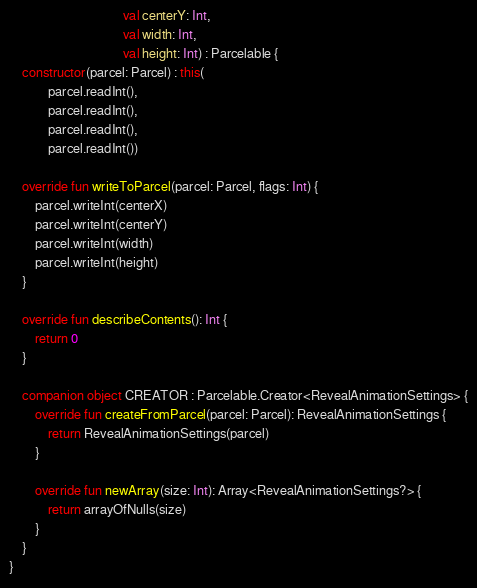Convert code to text. <code><loc_0><loc_0><loc_500><loc_500><_Kotlin_>                                   val centerY: Int,
                                   val width: Int,
                                   val height: Int) : Parcelable {
    constructor(parcel: Parcel) : this(
            parcel.readInt(),
            parcel.readInt(),
            parcel.readInt(),
            parcel.readInt())

    override fun writeToParcel(parcel: Parcel, flags: Int) {
        parcel.writeInt(centerX)
        parcel.writeInt(centerY)
        parcel.writeInt(width)
        parcel.writeInt(height)
    }

    override fun describeContents(): Int {
        return 0
    }

    companion object CREATOR : Parcelable.Creator<RevealAnimationSettings> {
        override fun createFromParcel(parcel: Parcel): RevealAnimationSettings {
            return RevealAnimationSettings(parcel)
        }

        override fun newArray(size: Int): Array<RevealAnimationSettings?> {
            return arrayOfNulls(size)
        }
    }
}
</code> 